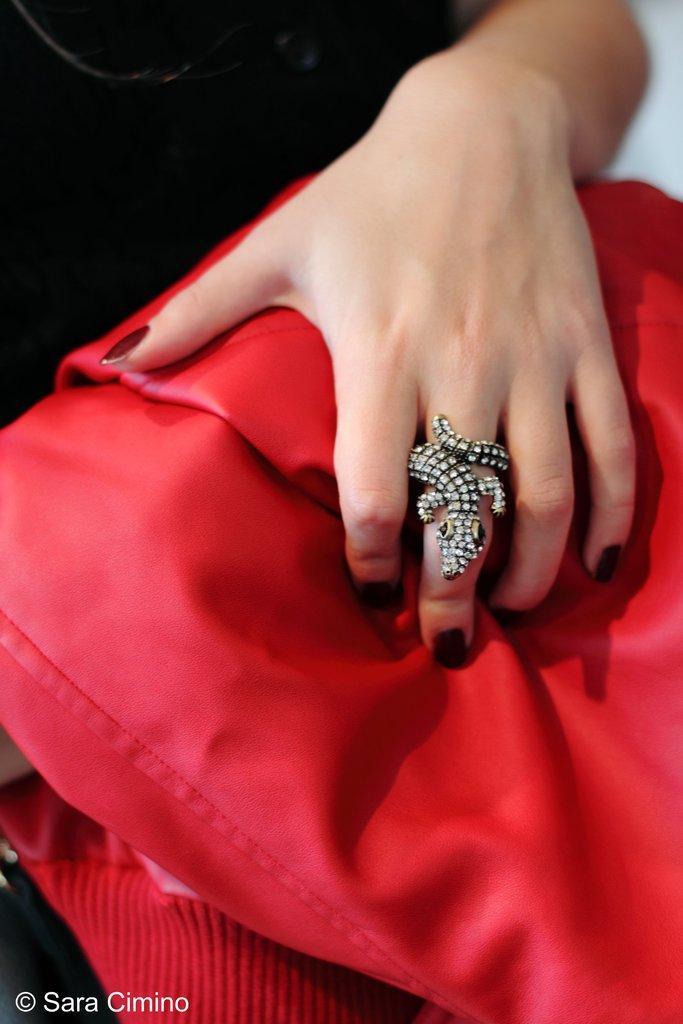Can you describe this image briefly? In this image I can see a person hand and ring. I can see a red color cloth. 